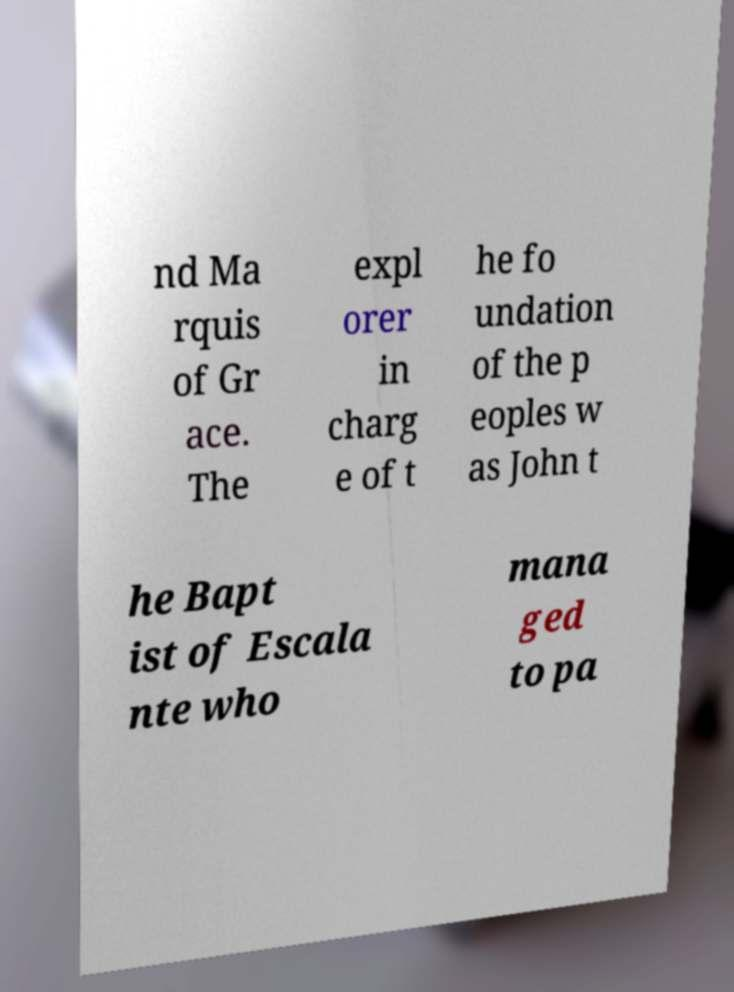Can you read and provide the text displayed in the image?This photo seems to have some interesting text. Can you extract and type it out for me? nd Ma rquis of Gr ace. The expl orer in charg e of t he fo undation of the p eoples w as John t he Bapt ist of Escala nte who mana ged to pa 